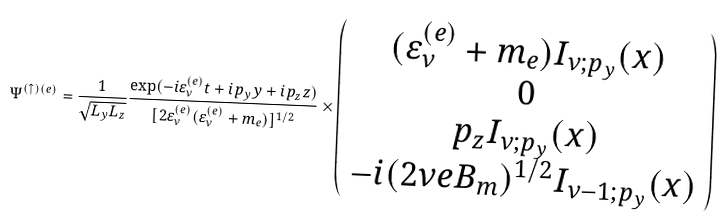<formula> <loc_0><loc_0><loc_500><loc_500>\Psi ^ { ( \uparrow ) ( e ) } = \frac { 1 } { \sqrt { L _ { y } L _ { z } } } \frac { \exp ( - i \varepsilon _ { \nu } ^ { ( e ) } t + i p _ { y } y + i p _ { z } z ) } { [ 2 \varepsilon _ { \nu } ^ { ( e ) } ( \varepsilon _ { \nu } ^ { ( e ) } + m _ { e } ) ] ^ { 1 / 2 } } \times \left ( \begin{array} { c } ( \varepsilon _ { \nu } ^ { ( e ) } + m _ { e } ) I _ { \nu ; p _ { y } } ( x ) \\ 0 \\ p _ { z } I _ { \nu ; p _ { y } } ( x ) \\ - i ( 2 \nu e B _ { m } ) ^ { 1 / 2 } I _ { \nu - 1 ; p _ { y } } ( x ) \end{array} \right )</formula> 